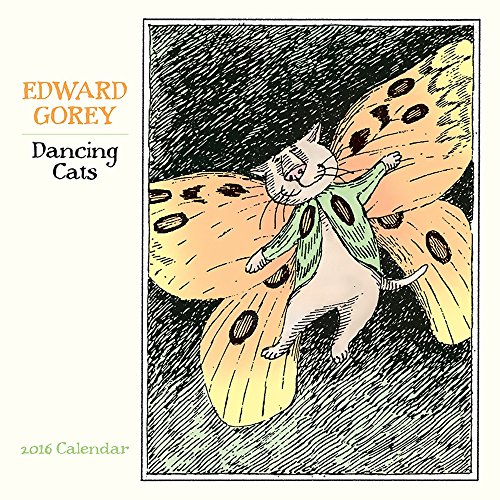Who wrote this book? Edward Gorey, an American writer and artist known for his illustrated books with whimsical and sometimes macabre themes, is the author responsible for this delightful calendar book. 